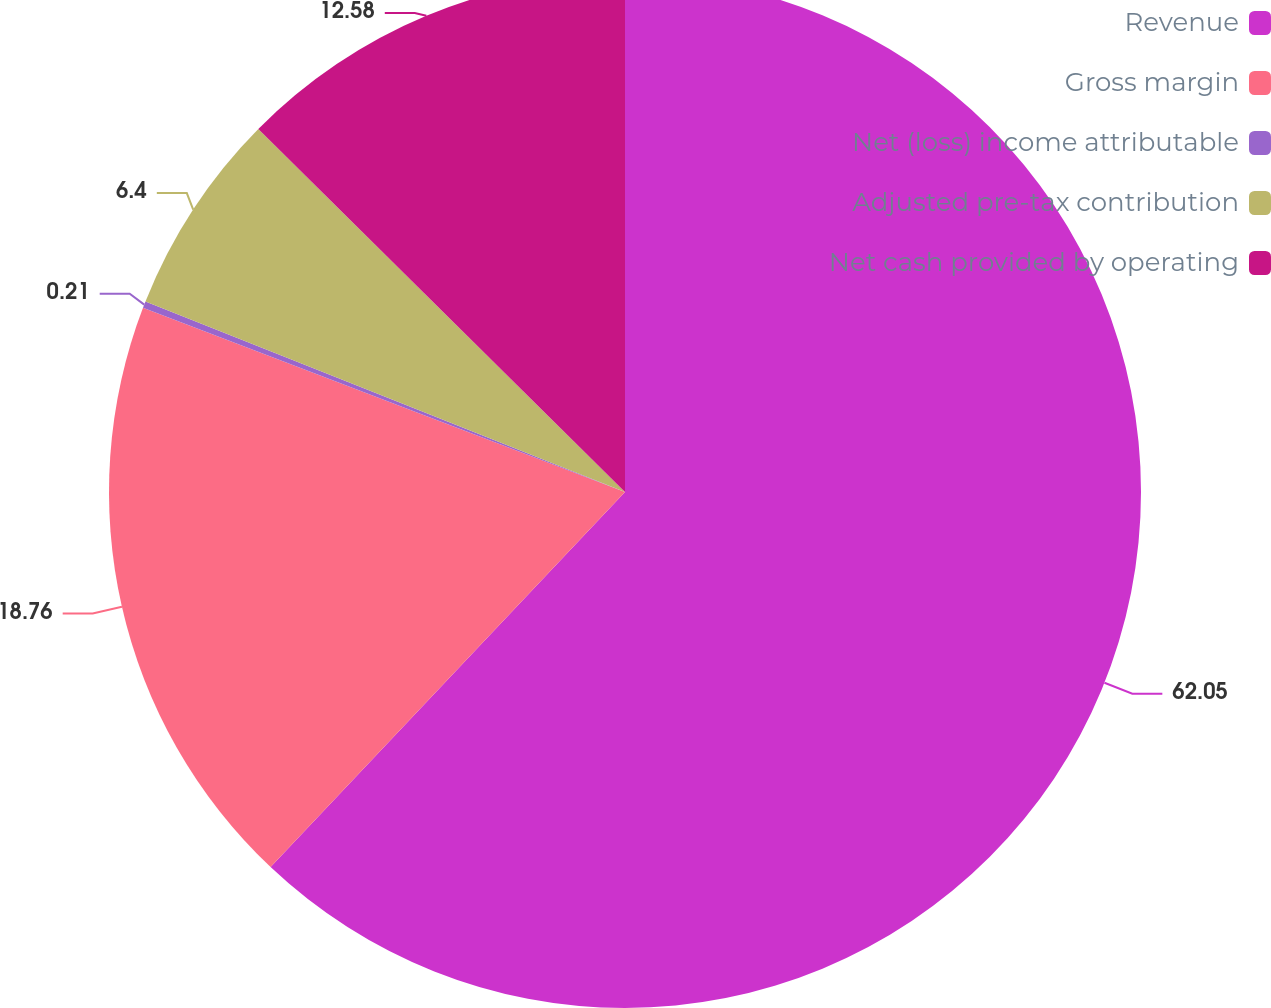Convert chart. <chart><loc_0><loc_0><loc_500><loc_500><pie_chart><fcel>Revenue<fcel>Gross margin<fcel>Net (loss) income attributable<fcel>Adjusted pre-tax contribution<fcel>Net cash provided by operating<nl><fcel>62.05%<fcel>18.76%<fcel>0.21%<fcel>6.4%<fcel>12.58%<nl></chart> 